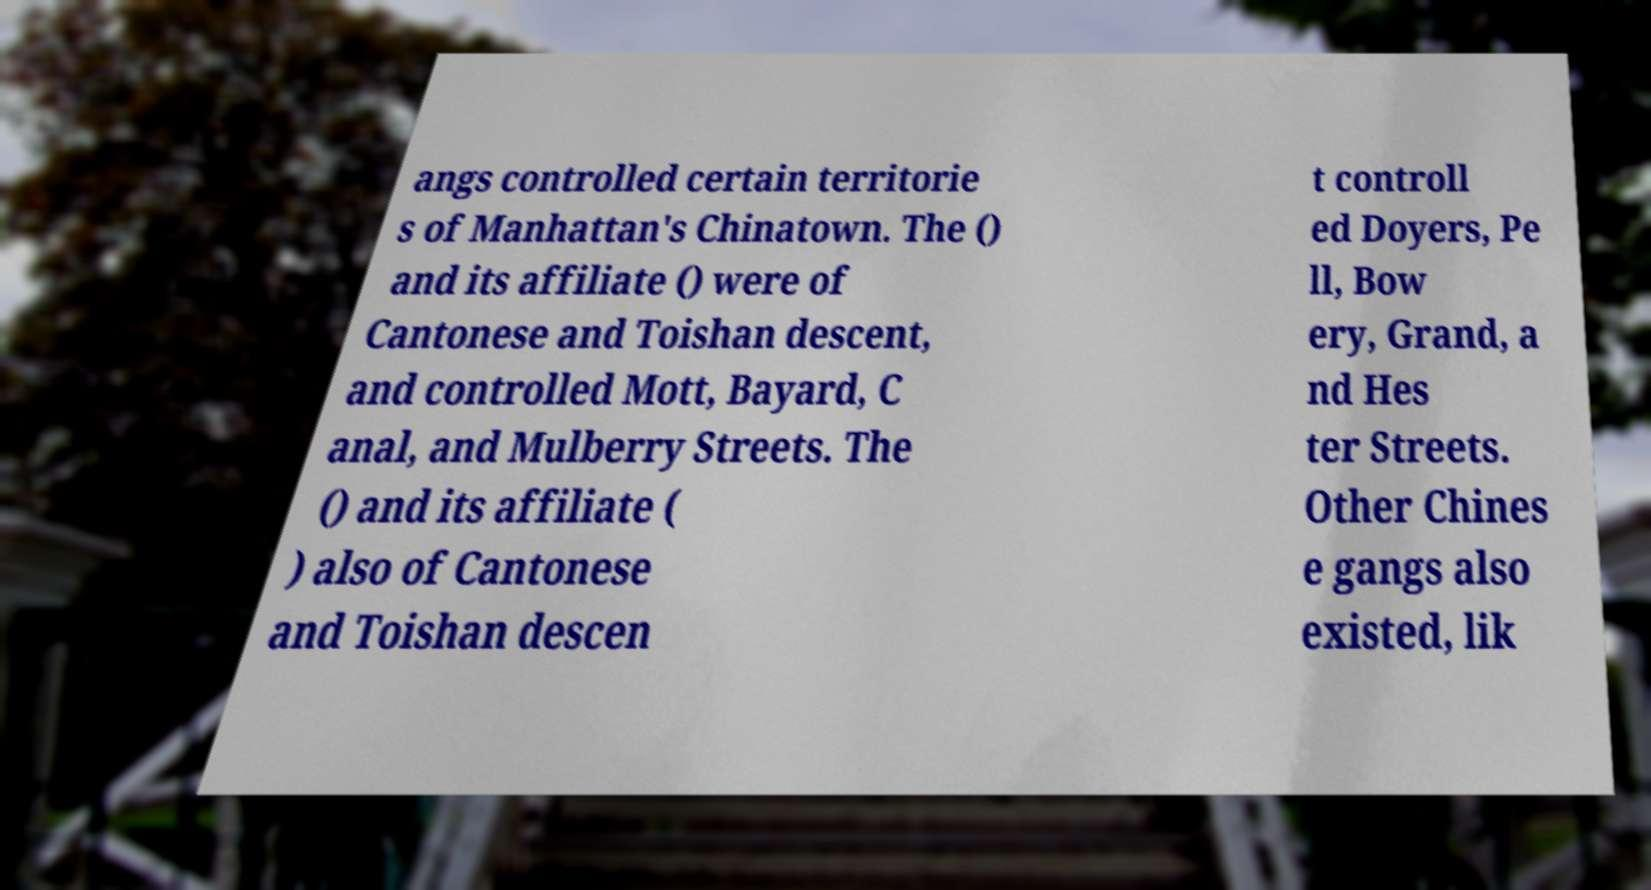Please read and relay the text visible in this image. What does it say? angs controlled certain territorie s of Manhattan's Chinatown. The () and its affiliate () were of Cantonese and Toishan descent, and controlled Mott, Bayard, C anal, and Mulberry Streets. The () and its affiliate ( ) also of Cantonese and Toishan descen t controll ed Doyers, Pe ll, Bow ery, Grand, a nd Hes ter Streets. Other Chines e gangs also existed, lik 